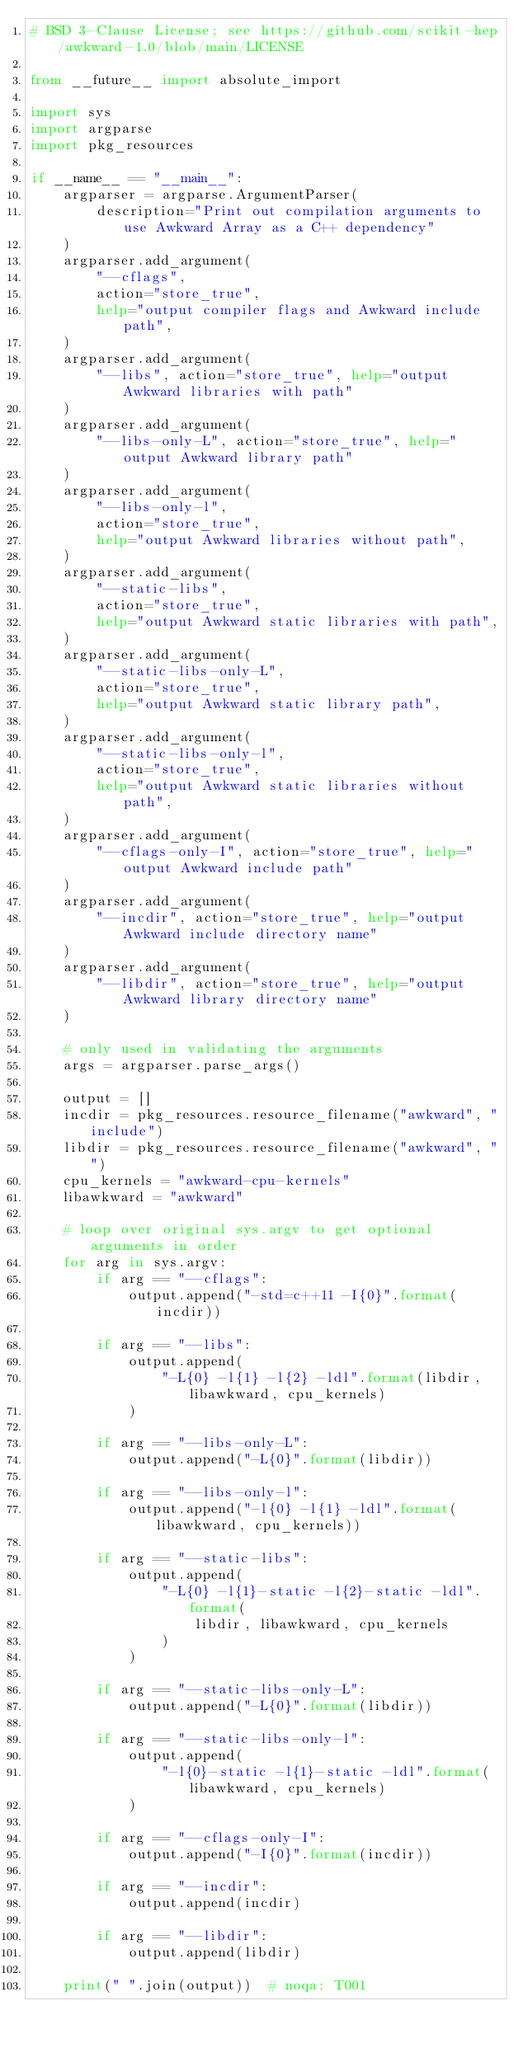<code> <loc_0><loc_0><loc_500><loc_500><_Python_># BSD 3-Clause License; see https://github.com/scikit-hep/awkward-1.0/blob/main/LICENSE

from __future__ import absolute_import

import sys
import argparse
import pkg_resources

if __name__ == "__main__":
    argparser = argparse.ArgumentParser(
        description="Print out compilation arguments to use Awkward Array as a C++ dependency"
    )
    argparser.add_argument(
        "--cflags",
        action="store_true",
        help="output compiler flags and Awkward include path",
    )
    argparser.add_argument(
        "--libs", action="store_true", help="output Awkward libraries with path"
    )
    argparser.add_argument(
        "--libs-only-L", action="store_true", help="output Awkward library path"
    )
    argparser.add_argument(
        "--libs-only-l",
        action="store_true",
        help="output Awkward libraries without path",
    )
    argparser.add_argument(
        "--static-libs",
        action="store_true",
        help="output Awkward static libraries with path",
    )
    argparser.add_argument(
        "--static-libs-only-L",
        action="store_true",
        help="output Awkward static library path",
    )
    argparser.add_argument(
        "--static-libs-only-l",
        action="store_true",
        help="output Awkward static libraries without path",
    )
    argparser.add_argument(
        "--cflags-only-I", action="store_true", help="output Awkward include path"
    )
    argparser.add_argument(
        "--incdir", action="store_true", help="output Awkward include directory name"
    )
    argparser.add_argument(
        "--libdir", action="store_true", help="output Awkward library directory name"
    )

    # only used in validating the arguments
    args = argparser.parse_args()

    output = []
    incdir = pkg_resources.resource_filename("awkward", "include")
    libdir = pkg_resources.resource_filename("awkward", "")
    cpu_kernels = "awkward-cpu-kernels"
    libawkward = "awkward"

    # loop over original sys.argv to get optional arguments in order
    for arg in sys.argv:
        if arg == "--cflags":
            output.append("-std=c++11 -I{0}".format(incdir))

        if arg == "--libs":
            output.append(
                "-L{0} -l{1} -l{2} -ldl".format(libdir, libawkward, cpu_kernels)
            )

        if arg == "--libs-only-L":
            output.append("-L{0}".format(libdir))

        if arg == "--libs-only-l":
            output.append("-l{0} -l{1} -ldl".format(libawkward, cpu_kernels))

        if arg == "--static-libs":
            output.append(
                "-L{0} -l{1}-static -l{2}-static -ldl".format(
                    libdir, libawkward, cpu_kernels
                )
            )

        if arg == "--static-libs-only-L":
            output.append("-L{0}".format(libdir))

        if arg == "--static-libs-only-l":
            output.append(
                "-l{0}-static -l{1}-static -ldl".format(libawkward, cpu_kernels)
            )

        if arg == "--cflags-only-I":
            output.append("-I{0}".format(incdir))

        if arg == "--incdir":
            output.append(incdir)

        if arg == "--libdir":
            output.append(libdir)

    print(" ".join(output))  # noqa: T001
</code> 